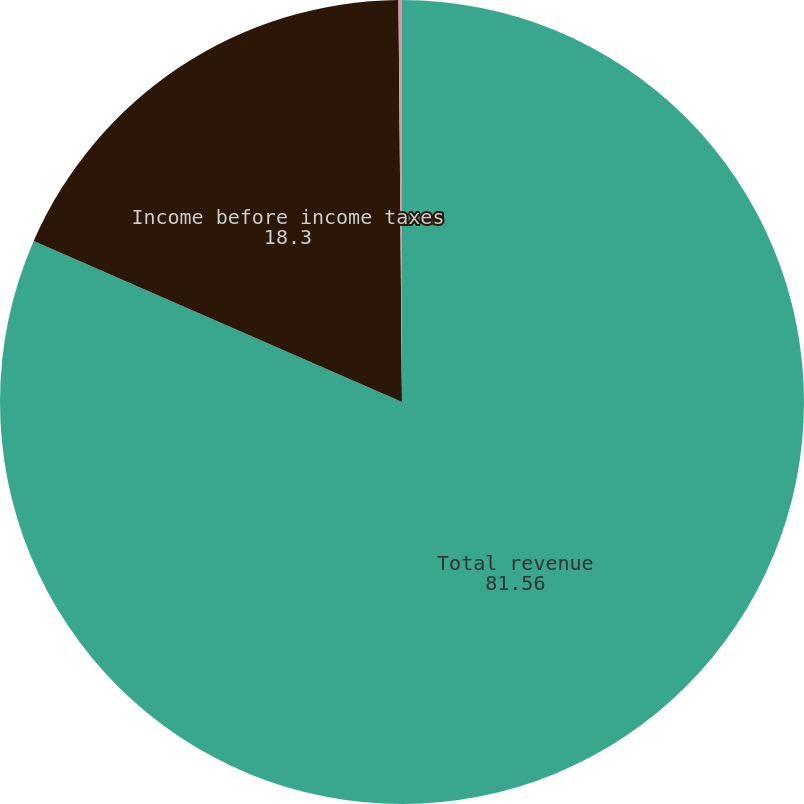Convert chart. <chart><loc_0><loc_0><loc_500><loc_500><pie_chart><fcel>Total revenue<fcel>Income before income taxes<fcel>Average assets (billions)<nl><fcel>81.56%<fcel>18.3%<fcel>0.14%<nl></chart> 